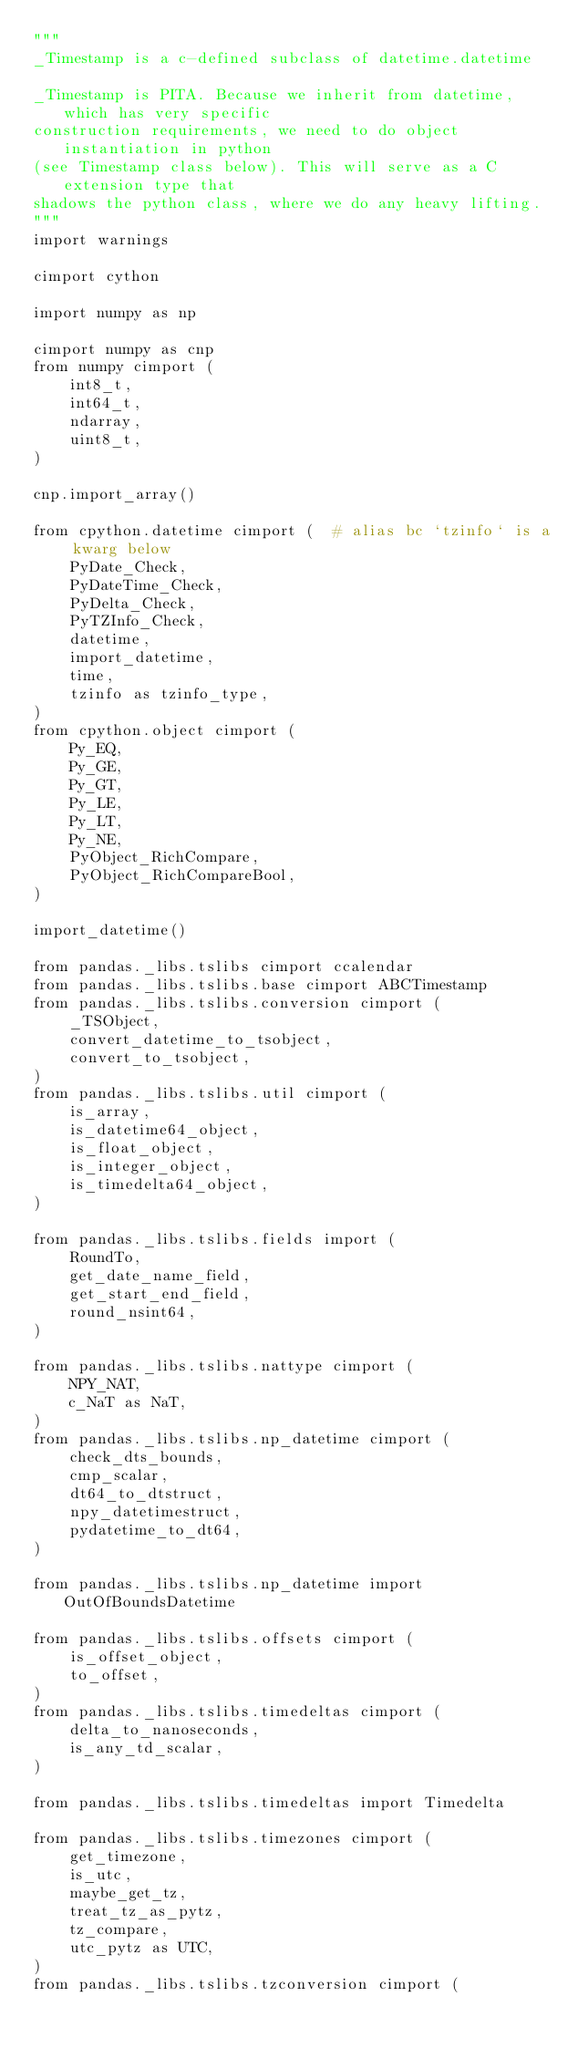<code> <loc_0><loc_0><loc_500><loc_500><_Cython_>"""
_Timestamp is a c-defined subclass of datetime.datetime

_Timestamp is PITA. Because we inherit from datetime, which has very specific
construction requirements, we need to do object instantiation in python
(see Timestamp class below). This will serve as a C extension type that
shadows the python class, where we do any heavy lifting.
"""
import warnings

cimport cython

import numpy as np

cimport numpy as cnp
from numpy cimport (
    int8_t,
    int64_t,
    ndarray,
    uint8_t,
)

cnp.import_array()

from cpython.datetime cimport (  # alias bc `tzinfo` is a kwarg below
    PyDate_Check,
    PyDateTime_Check,
    PyDelta_Check,
    PyTZInfo_Check,
    datetime,
    import_datetime,
    time,
    tzinfo as tzinfo_type,
)
from cpython.object cimport (
    Py_EQ,
    Py_GE,
    Py_GT,
    Py_LE,
    Py_LT,
    Py_NE,
    PyObject_RichCompare,
    PyObject_RichCompareBool,
)

import_datetime()

from pandas._libs.tslibs cimport ccalendar
from pandas._libs.tslibs.base cimport ABCTimestamp
from pandas._libs.tslibs.conversion cimport (
    _TSObject,
    convert_datetime_to_tsobject,
    convert_to_tsobject,
)
from pandas._libs.tslibs.util cimport (
    is_array,
    is_datetime64_object,
    is_float_object,
    is_integer_object,
    is_timedelta64_object,
)

from pandas._libs.tslibs.fields import (
    RoundTo,
    get_date_name_field,
    get_start_end_field,
    round_nsint64,
)

from pandas._libs.tslibs.nattype cimport (
    NPY_NAT,
    c_NaT as NaT,
)
from pandas._libs.tslibs.np_datetime cimport (
    check_dts_bounds,
    cmp_scalar,
    dt64_to_dtstruct,
    npy_datetimestruct,
    pydatetime_to_dt64,
)

from pandas._libs.tslibs.np_datetime import OutOfBoundsDatetime

from pandas._libs.tslibs.offsets cimport (
    is_offset_object,
    to_offset,
)
from pandas._libs.tslibs.timedeltas cimport (
    delta_to_nanoseconds,
    is_any_td_scalar,
)

from pandas._libs.tslibs.timedeltas import Timedelta

from pandas._libs.tslibs.timezones cimport (
    get_timezone,
    is_utc,
    maybe_get_tz,
    treat_tz_as_pytz,
    tz_compare,
    utc_pytz as UTC,
)
from pandas._libs.tslibs.tzconversion cimport (</code> 